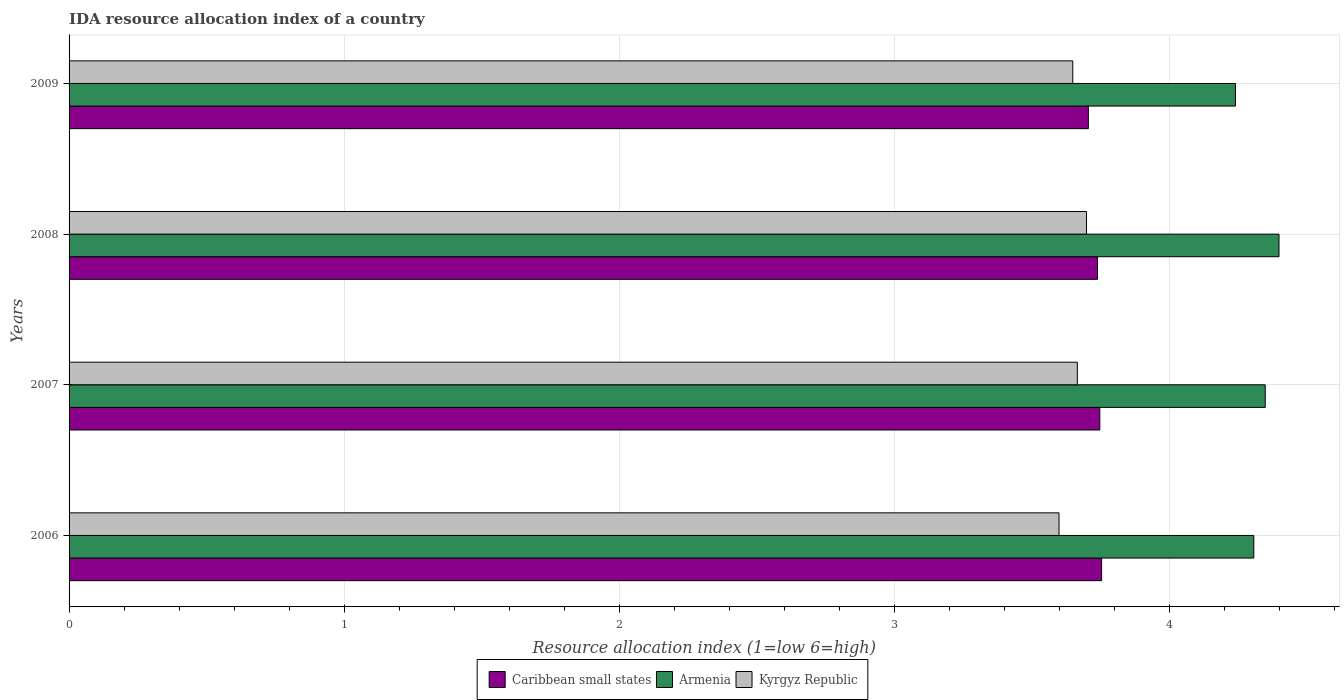How many groups of bars are there?
Your answer should be very brief. 4. Are the number of bars per tick equal to the number of legend labels?
Offer a terse response. Yes. How many bars are there on the 1st tick from the top?
Keep it short and to the point. 3. How many bars are there on the 3rd tick from the bottom?
Provide a succinct answer. 3. What is the label of the 4th group of bars from the top?
Offer a very short reply. 2006. What is the IDA resource allocation index in Caribbean small states in 2007?
Your answer should be very brief. 3.75. Across all years, what is the maximum IDA resource allocation index in Caribbean small states?
Offer a very short reply. 3.75. Across all years, what is the minimum IDA resource allocation index in Caribbean small states?
Your response must be concise. 3.71. In which year was the IDA resource allocation index in Kyrgyz Republic maximum?
Your response must be concise. 2008. What is the difference between the IDA resource allocation index in Armenia in 2007 and that in 2009?
Make the answer very short. 0.11. What is the difference between the IDA resource allocation index in Caribbean small states in 2009 and the IDA resource allocation index in Kyrgyz Republic in 2008?
Your answer should be very brief. 0.01. What is the average IDA resource allocation index in Caribbean small states per year?
Provide a short and direct response. 3.74. In the year 2009, what is the difference between the IDA resource allocation index in Caribbean small states and IDA resource allocation index in Armenia?
Provide a succinct answer. -0.53. What is the ratio of the IDA resource allocation index in Kyrgyz Republic in 2007 to that in 2008?
Offer a very short reply. 0.99. What is the difference between the highest and the second highest IDA resource allocation index in Kyrgyz Republic?
Your answer should be compact. 0.03. What is the difference between the highest and the lowest IDA resource allocation index in Armenia?
Provide a succinct answer. 0.16. In how many years, is the IDA resource allocation index in Caribbean small states greater than the average IDA resource allocation index in Caribbean small states taken over all years?
Offer a terse response. 3. Is the sum of the IDA resource allocation index in Caribbean small states in 2006 and 2009 greater than the maximum IDA resource allocation index in Kyrgyz Republic across all years?
Make the answer very short. Yes. What does the 1st bar from the top in 2007 represents?
Provide a short and direct response. Kyrgyz Republic. What does the 2nd bar from the bottom in 2009 represents?
Offer a terse response. Armenia. Are all the bars in the graph horizontal?
Offer a terse response. Yes. Does the graph contain any zero values?
Ensure brevity in your answer.  No. What is the title of the graph?
Your response must be concise. IDA resource allocation index of a country. What is the label or title of the X-axis?
Provide a short and direct response. Resource allocation index (1=low 6=high). What is the Resource allocation index (1=low 6=high) in Caribbean small states in 2006?
Offer a terse response. 3.75. What is the Resource allocation index (1=low 6=high) in Armenia in 2006?
Give a very brief answer. 4.31. What is the Resource allocation index (1=low 6=high) in Kyrgyz Republic in 2006?
Give a very brief answer. 3.6. What is the Resource allocation index (1=low 6=high) of Caribbean small states in 2007?
Make the answer very short. 3.75. What is the Resource allocation index (1=low 6=high) in Armenia in 2007?
Your answer should be compact. 4.35. What is the Resource allocation index (1=low 6=high) in Kyrgyz Republic in 2007?
Your response must be concise. 3.67. What is the Resource allocation index (1=low 6=high) of Caribbean small states in 2008?
Your response must be concise. 3.74. What is the Resource allocation index (1=low 6=high) of Armenia in 2008?
Make the answer very short. 4.4. What is the Resource allocation index (1=low 6=high) in Caribbean small states in 2009?
Give a very brief answer. 3.71. What is the Resource allocation index (1=low 6=high) in Armenia in 2009?
Make the answer very short. 4.24. What is the Resource allocation index (1=low 6=high) in Kyrgyz Republic in 2009?
Offer a terse response. 3.65. Across all years, what is the maximum Resource allocation index (1=low 6=high) of Caribbean small states?
Your answer should be very brief. 3.75. Across all years, what is the maximum Resource allocation index (1=low 6=high) of Armenia?
Offer a terse response. 4.4. Across all years, what is the minimum Resource allocation index (1=low 6=high) in Caribbean small states?
Offer a very short reply. 3.71. Across all years, what is the minimum Resource allocation index (1=low 6=high) in Armenia?
Your response must be concise. 4.24. What is the total Resource allocation index (1=low 6=high) of Caribbean small states in the graph?
Your response must be concise. 14.95. What is the total Resource allocation index (1=low 6=high) of Armenia in the graph?
Your response must be concise. 17.3. What is the total Resource allocation index (1=low 6=high) of Kyrgyz Republic in the graph?
Provide a succinct answer. 14.62. What is the difference between the Resource allocation index (1=low 6=high) of Caribbean small states in 2006 and that in 2007?
Your answer should be compact. 0.01. What is the difference between the Resource allocation index (1=low 6=high) in Armenia in 2006 and that in 2007?
Your answer should be compact. -0.04. What is the difference between the Resource allocation index (1=low 6=high) of Kyrgyz Republic in 2006 and that in 2007?
Provide a short and direct response. -0.07. What is the difference between the Resource allocation index (1=low 6=high) in Caribbean small states in 2006 and that in 2008?
Offer a terse response. 0.01. What is the difference between the Resource allocation index (1=low 6=high) in Armenia in 2006 and that in 2008?
Offer a very short reply. -0.09. What is the difference between the Resource allocation index (1=low 6=high) in Caribbean small states in 2006 and that in 2009?
Your answer should be compact. 0.05. What is the difference between the Resource allocation index (1=low 6=high) in Armenia in 2006 and that in 2009?
Provide a succinct answer. 0.07. What is the difference between the Resource allocation index (1=low 6=high) in Caribbean small states in 2007 and that in 2008?
Provide a short and direct response. 0.01. What is the difference between the Resource allocation index (1=low 6=high) in Armenia in 2007 and that in 2008?
Provide a short and direct response. -0.05. What is the difference between the Resource allocation index (1=low 6=high) of Kyrgyz Republic in 2007 and that in 2008?
Ensure brevity in your answer.  -0.03. What is the difference between the Resource allocation index (1=low 6=high) in Caribbean small states in 2007 and that in 2009?
Offer a terse response. 0.04. What is the difference between the Resource allocation index (1=low 6=high) of Armenia in 2007 and that in 2009?
Your answer should be very brief. 0.11. What is the difference between the Resource allocation index (1=low 6=high) of Kyrgyz Republic in 2007 and that in 2009?
Give a very brief answer. 0.02. What is the difference between the Resource allocation index (1=low 6=high) of Caribbean small states in 2008 and that in 2009?
Offer a terse response. 0.03. What is the difference between the Resource allocation index (1=low 6=high) in Armenia in 2008 and that in 2009?
Make the answer very short. 0.16. What is the difference between the Resource allocation index (1=low 6=high) of Caribbean small states in 2006 and the Resource allocation index (1=low 6=high) of Armenia in 2007?
Your answer should be compact. -0.59. What is the difference between the Resource allocation index (1=low 6=high) in Caribbean small states in 2006 and the Resource allocation index (1=low 6=high) in Kyrgyz Republic in 2007?
Your response must be concise. 0.09. What is the difference between the Resource allocation index (1=low 6=high) in Armenia in 2006 and the Resource allocation index (1=low 6=high) in Kyrgyz Republic in 2007?
Make the answer very short. 0.64. What is the difference between the Resource allocation index (1=low 6=high) of Caribbean small states in 2006 and the Resource allocation index (1=low 6=high) of Armenia in 2008?
Offer a very short reply. -0.65. What is the difference between the Resource allocation index (1=low 6=high) in Caribbean small states in 2006 and the Resource allocation index (1=low 6=high) in Kyrgyz Republic in 2008?
Keep it short and to the point. 0.06. What is the difference between the Resource allocation index (1=low 6=high) in Armenia in 2006 and the Resource allocation index (1=low 6=high) in Kyrgyz Republic in 2008?
Your response must be concise. 0.61. What is the difference between the Resource allocation index (1=low 6=high) in Caribbean small states in 2006 and the Resource allocation index (1=low 6=high) in Armenia in 2009?
Offer a terse response. -0.49. What is the difference between the Resource allocation index (1=low 6=high) in Caribbean small states in 2006 and the Resource allocation index (1=low 6=high) in Kyrgyz Republic in 2009?
Provide a short and direct response. 0.1. What is the difference between the Resource allocation index (1=low 6=high) of Armenia in 2006 and the Resource allocation index (1=low 6=high) of Kyrgyz Republic in 2009?
Provide a succinct answer. 0.66. What is the difference between the Resource allocation index (1=low 6=high) of Caribbean small states in 2007 and the Resource allocation index (1=low 6=high) of Armenia in 2008?
Provide a succinct answer. -0.65. What is the difference between the Resource allocation index (1=low 6=high) of Caribbean small states in 2007 and the Resource allocation index (1=low 6=high) of Kyrgyz Republic in 2008?
Your response must be concise. 0.05. What is the difference between the Resource allocation index (1=low 6=high) of Armenia in 2007 and the Resource allocation index (1=low 6=high) of Kyrgyz Republic in 2008?
Your response must be concise. 0.65. What is the difference between the Resource allocation index (1=low 6=high) in Caribbean small states in 2007 and the Resource allocation index (1=low 6=high) in Armenia in 2009?
Provide a short and direct response. -0.49. What is the difference between the Resource allocation index (1=low 6=high) of Caribbean small states in 2007 and the Resource allocation index (1=low 6=high) of Kyrgyz Republic in 2009?
Make the answer very short. 0.1. What is the difference between the Resource allocation index (1=low 6=high) of Caribbean small states in 2008 and the Resource allocation index (1=low 6=high) of Armenia in 2009?
Your response must be concise. -0.5. What is the difference between the Resource allocation index (1=low 6=high) of Caribbean small states in 2008 and the Resource allocation index (1=low 6=high) of Kyrgyz Republic in 2009?
Your answer should be compact. 0.09. What is the average Resource allocation index (1=low 6=high) in Caribbean small states per year?
Your response must be concise. 3.74. What is the average Resource allocation index (1=low 6=high) in Armenia per year?
Your answer should be very brief. 4.33. What is the average Resource allocation index (1=low 6=high) in Kyrgyz Republic per year?
Your response must be concise. 3.65. In the year 2006, what is the difference between the Resource allocation index (1=low 6=high) in Caribbean small states and Resource allocation index (1=low 6=high) in Armenia?
Make the answer very short. -0.55. In the year 2006, what is the difference between the Resource allocation index (1=low 6=high) of Caribbean small states and Resource allocation index (1=low 6=high) of Kyrgyz Republic?
Your response must be concise. 0.15. In the year 2006, what is the difference between the Resource allocation index (1=low 6=high) in Armenia and Resource allocation index (1=low 6=high) in Kyrgyz Republic?
Your answer should be very brief. 0.71. In the year 2007, what is the difference between the Resource allocation index (1=low 6=high) of Caribbean small states and Resource allocation index (1=low 6=high) of Armenia?
Your answer should be very brief. -0.6. In the year 2007, what is the difference between the Resource allocation index (1=low 6=high) in Caribbean small states and Resource allocation index (1=low 6=high) in Kyrgyz Republic?
Offer a terse response. 0.08. In the year 2007, what is the difference between the Resource allocation index (1=low 6=high) in Armenia and Resource allocation index (1=low 6=high) in Kyrgyz Republic?
Your response must be concise. 0.68. In the year 2008, what is the difference between the Resource allocation index (1=low 6=high) of Caribbean small states and Resource allocation index (1=low 6=high) of Armenia?
Keep it short and to the point. -0.66. In the year 2008, what is the difference between the Resource allocation index (1=low 6=high) in Caribbean small states and Resource allocation index (1=low 6=high) in Kyrgyz Republic?
Ensure brevity in your answer.  0.04. In the year 2009, what is the difference between the Resource allocation index (1=low 6=high) of Caribbean small states and Resource allocation index (1=low 6=high) of Armenia?
Offer a terse response. -0.54. In the year 2009, what is the difference between the Resource allocation index (1=low 6=high) of Caribbean small states and Resource allocation index (1=low 6=high) of Kyrgyz Republic?
Offer a very short reply. 0.06. In the year 2009, what is the difference between the Resource allocation index (1=low 6=high) in Armenia and Resource allocation index (1=low 6=high) in Kyrgyz Republic?
Your answer should be very brief. 0.59. What is the ratio of the Resource allocation index (1=low 6=high) of Kyrgyz Republic in 2006 to that in 2007?
Provide a short and direct response. 0.98. What is the ratio of the Resource allocation index (1=low 6=high) in Armenia in 2006 to that in 2008?
Offer a terse response. 0.98. What is the ratio of the Resource allocation index (1=low 6=high) of Kyrgyz Republic in 2006 to that in 2008?
Provide a succinct answer. 0.97. What is the ratio of the Resource allocation index (1=low 6=high) of Armenia in 2006 to that in 2009?
Ensure brevity in your answer.  1.02. What is the ratio of the Resource allocation index (1=low 6=high) of Kyrgyz Republic in 2006 to that in 2009?
Provide a short and direct response. 0.99. What is the ratio of the Resource allocation index (1=low 6=high) in Armenia in 2007 to that in 2008?
Offer a terse response. 0.99. What is the ratio of the Resource allocation index (1=low 6=high) in Kyrgyz Republic in 2007 to that in 2008?
Keep it short and to the point. 0.99. What is the ratio of the Resource allocation index (1=low 6=high) of Caribbean small states in 2007 to that in 2009?
Your answer should be very brief. 1.01. What is the ratio of the Resource allocation index (1=low 6=high) of Armenia in 2007 to that in 2009?
Give a very brief answer. 1.03. What is the ratio of the Resource allocation index (1=low 6=high) in Caribbean small states in 2008 to that in 2009?
Your response must be concise. 1.01. What is the ratio of the Resource allocation index (1=low 6=high) of Armenia in 2008 to that in 2009?
Offer a very short reply. 1.04. What is the ratio of the Resource allocation index (1=low 6=high) in Kyrgyz Republic in 2008 to that in 2009?
Offer a very short reply. 1.01. What is the difference between the highest and the second highest Resource allocation index (1=low 6=high) of Caribbean small states?
Keep it short and to the point. 0.01. What is the difference between the highest and the second highest Resource allocation index (1=low 6=high) in Armenia?
Offer a very short reply. 0.05. What is the difference between the highest and the second highest Resource allocation index (1=low 6=high) in Kyrgyz Republic?
Provide a succinct answer. 0.03. What is the difference between the highest and the lowest Resource allocation index (1=low 6=high) of Caribbean small states?
Ensure brevity in your answer.  0.05. What is the difference between the highest and the lowest Resource allocation index (1=low 6=high) in Armenia?
Offer a terse response. 0.16. What is the difference between the highest and the lowest Resource allocation index (1=low 6=high) of Kyrgyz Republic?
Your response must be concise. 0.1. 